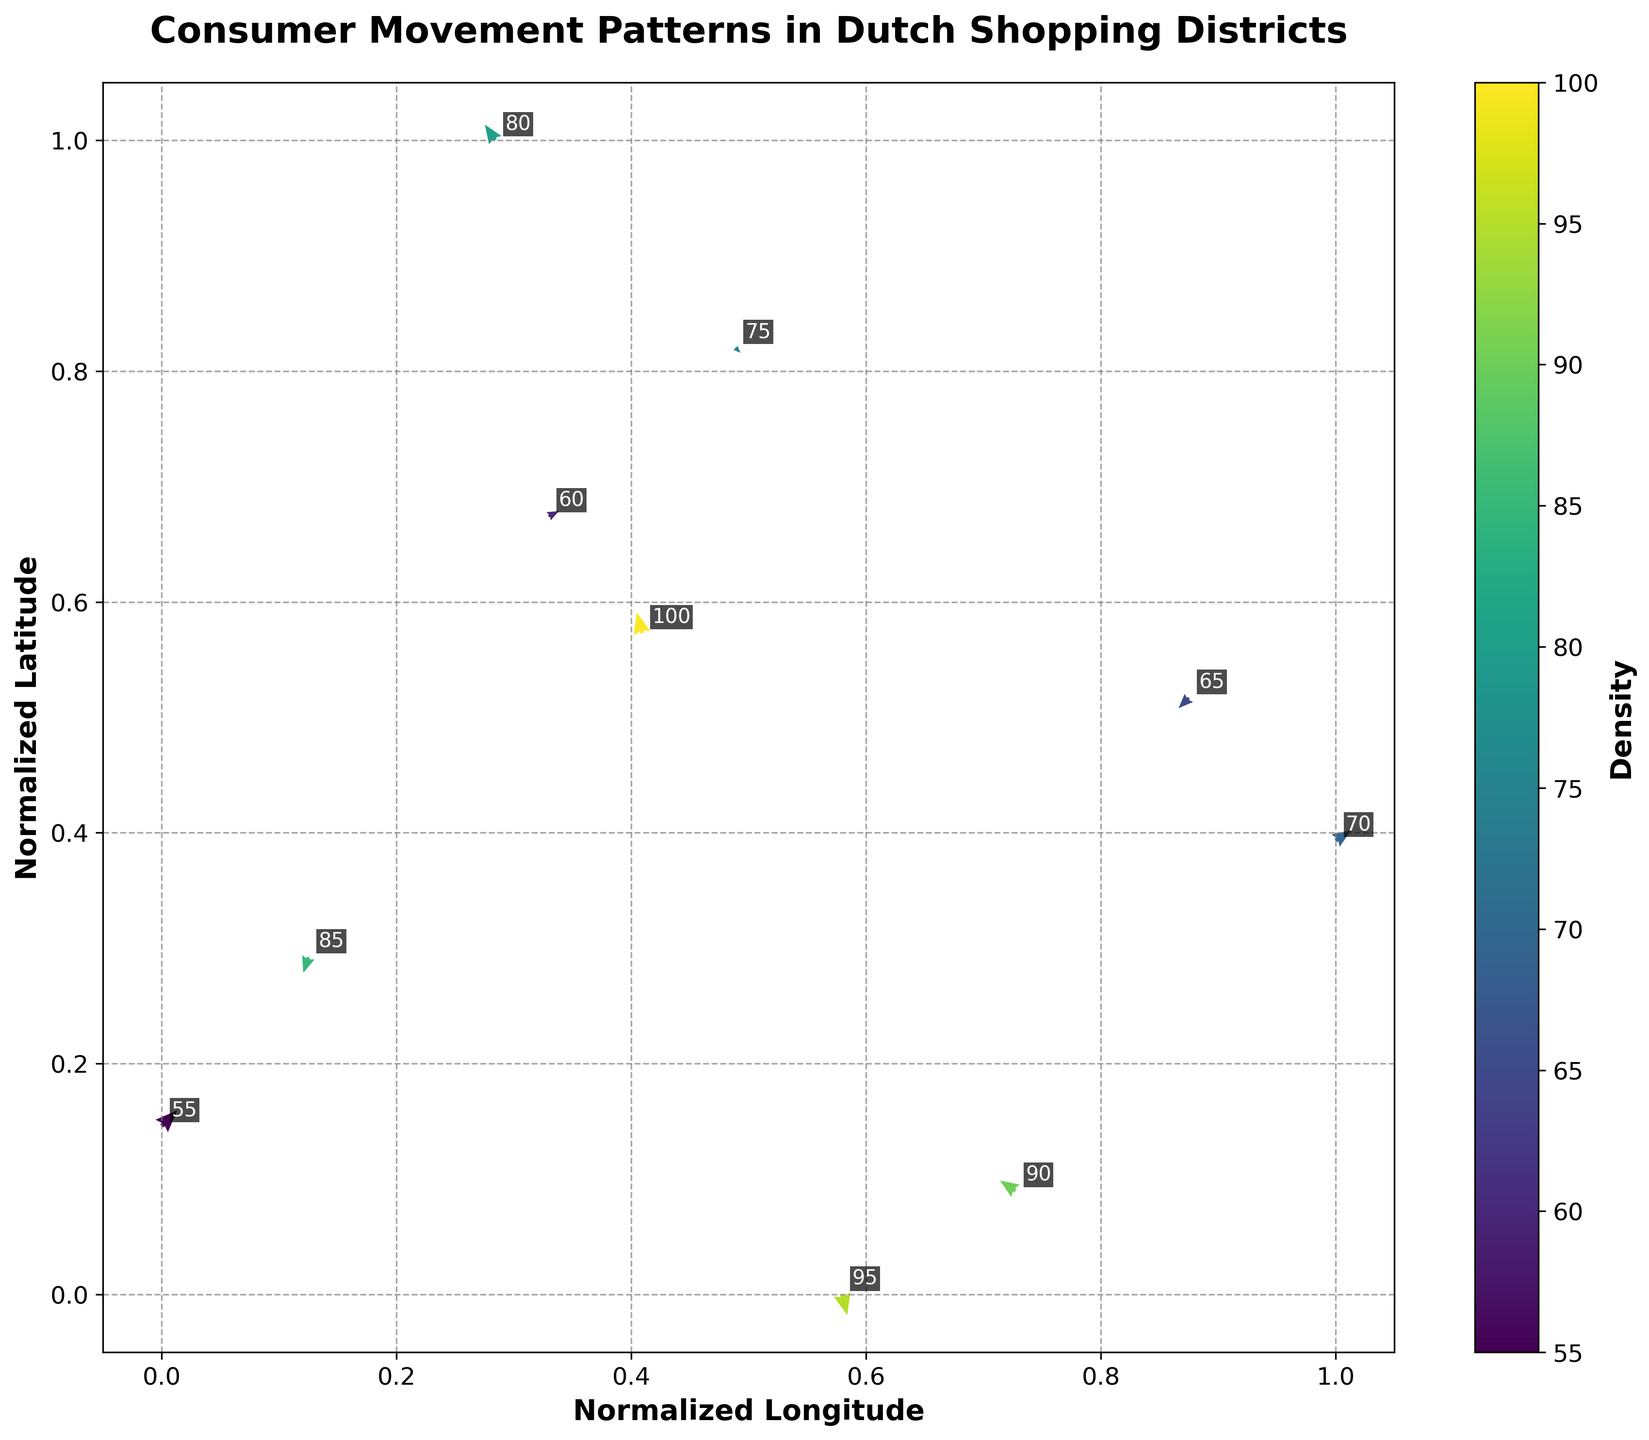What's the title of the plot? The title of the plot is usually displayed at the top center of the figure. In this case, you can see the title clearly.
Answer: Consumer Movement Patterns in Dutch Shopping Districts How many points are displayed in the plot? By counting the number of arrows or annotated data points within the plot, you can determine the total number.
Answer: 10 Which point has the highest density? You need to check the densities annotated next to each vector and identify the one with the maximum value.
Answer: 100 What is the direction of movement at coordinates (52.3702, 4.8952)? Look at the corresponding vector starting from these coordinates. The direction is given by the vector's 'u' and 'v' components. In this case, it points downwards and slightly to the right.
Answer: Downwards-right (-0.1, 0.4) Compare the density of the points at (52.3676, 4.9041) and (52.3715, 4.8960). Which one is higher? Look at the density values for the mentioned coordinates. The densities are 80 and 90, respectively. Therefore, the second point has a higher density.
Answer: 90 Which vector indicates the largest movement to the right? Identify the vector with the highest positive 'u' value, which corresponds to the largest rightward movement. The point at (52.3739, 4.8987) has a 'u' value of 0.3.
Answer: (52.3739, 4.8987) What is the average density of all points in the plot? Calculate the sum of all density values and divide by the total number of points. The sum is 800 and there are 10 points. The average density is 800/10.
Answer: 80 What is the cumulative vertical movement (sum of 'v' values) of all points? Sum up all the 'v' component values of the vectors. The individual 'v' values are 0.3, -0.4, 0.2, -0.3, 0.1, 0.2, -0.1, -0.2, 0.3, and 0.4. The sum is 0.5.
Answer: 0.5 Which point shows the largest upward movement? Look for the vector with the highest positive 'v' value. The vector at (52.3687, 4.9003) has the maximum 'v' value of 0.4.
Answer: (52.3687, 4.9003) What is represented by the color in the quiver plot? The color of the vectors is determined by the density values, providing a visual indication of density levels for different points. This is shown by the color bar on the side of the plot.
Answer: Density 